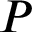Convert formula to latex. <formula><loc_0><loc_0><loc_500><loc_500>P</formula> 